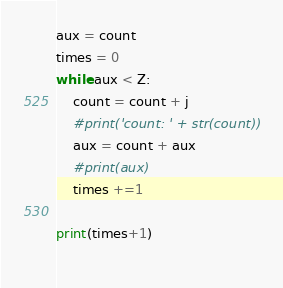Convert code to text. <code><loc_0><loc_0><loc_500><loc_500><_Python_>aux = count
times = 0
while aux < Z:
    count = count + j
    #print('count: ' + str(count))
    aux = count + aux
    #print(aux)
    times +=1

print(times+1)
    </code> 